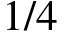Convert formula to latex. <formula><loc_0><loc_0><loc_500><loc_500>1 / 4</formula> 